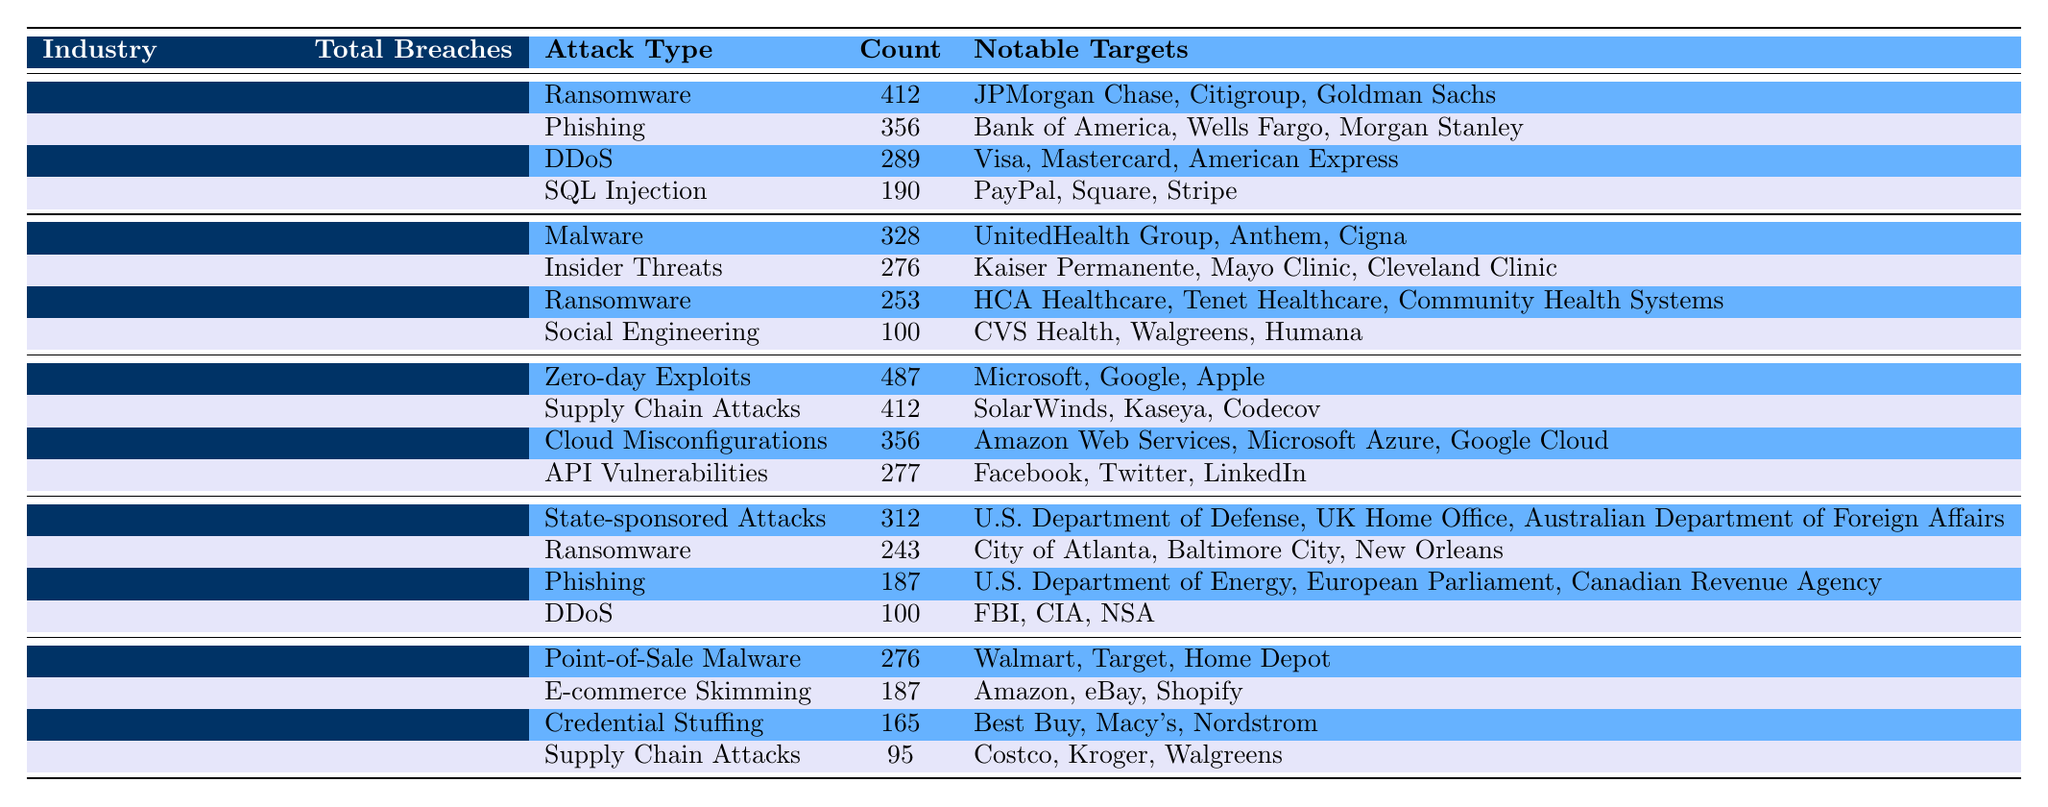What industry experienced the highest total number of breaches in 2022? The table shows that the Technology industry had the highest total breaches with a count of 1532.
Answer: Technology How many ransomware breaches occurred in the healthcare industry? In the healthcare section of the table, there are 253 ransomware breaches listed.
Answer: 253 Which industry had the least number of breaches? By examining the total breaches for each industry in the table, Retail had the least with a total of 723.
Answer: Retail What is the total number of breaches for Financial Services and Government combined? The total breaches for Financial Services is 1247 and for Government, it is 842. Adding these gives 1247 + 842 = 2089 total breaches.
Answer: 2089 In which industry was the most common attack type "Phishing"? Looking at the table, Phishing is listed as an attack type only for the Financial Services and Government industries, but it had more occurrences in Financial Services with 356 breaches compared to 187 in Government.
Answer: Financial Services What percentage of the total breaches in the Technology industry were due to Zero-day Exploits? The count for Zero-day Exploits in Technology is 487, and the total breaches for Technology are 1532. To find the percentage, we do (487 / 1532) * 100 = 31.8%.
Answer: 31.8% Which notable target was attacked most frequently in the Healthcare industry? The notable target most frequently mentioned for any attack type in the Healthcare industry is HCA Healthcare, which was involved in the Ransomware breaches (253) that were significant. However, there's no specific tally for individual targets across types.
Answer: HCA Healthcare Is the number of breaches in the retail industry higher than that in government? The Retail industry has 723 breaches while the Government industry has 842 breaches. Therefore, the number of breaches in Retail is not higher than in Government.
Answer: No If we combine the counts of “Cloud Misconfigurations” and “API Vulnerabilities”, what is the total for the Technology industry? The counts are 356 for Cloud Misconfigurations and 277 for API Vulnerabilities. Summing these gives 356 + 277 = 633 for the Technology industry.
Answer: 633 Which attack type was prominent in both Financial Services and Government sectors? Ransomware appears in both Financial Services with 412 counts and Government with 243 counts, making it a prominent attack type in both sectors.
Answer: Ransomware 